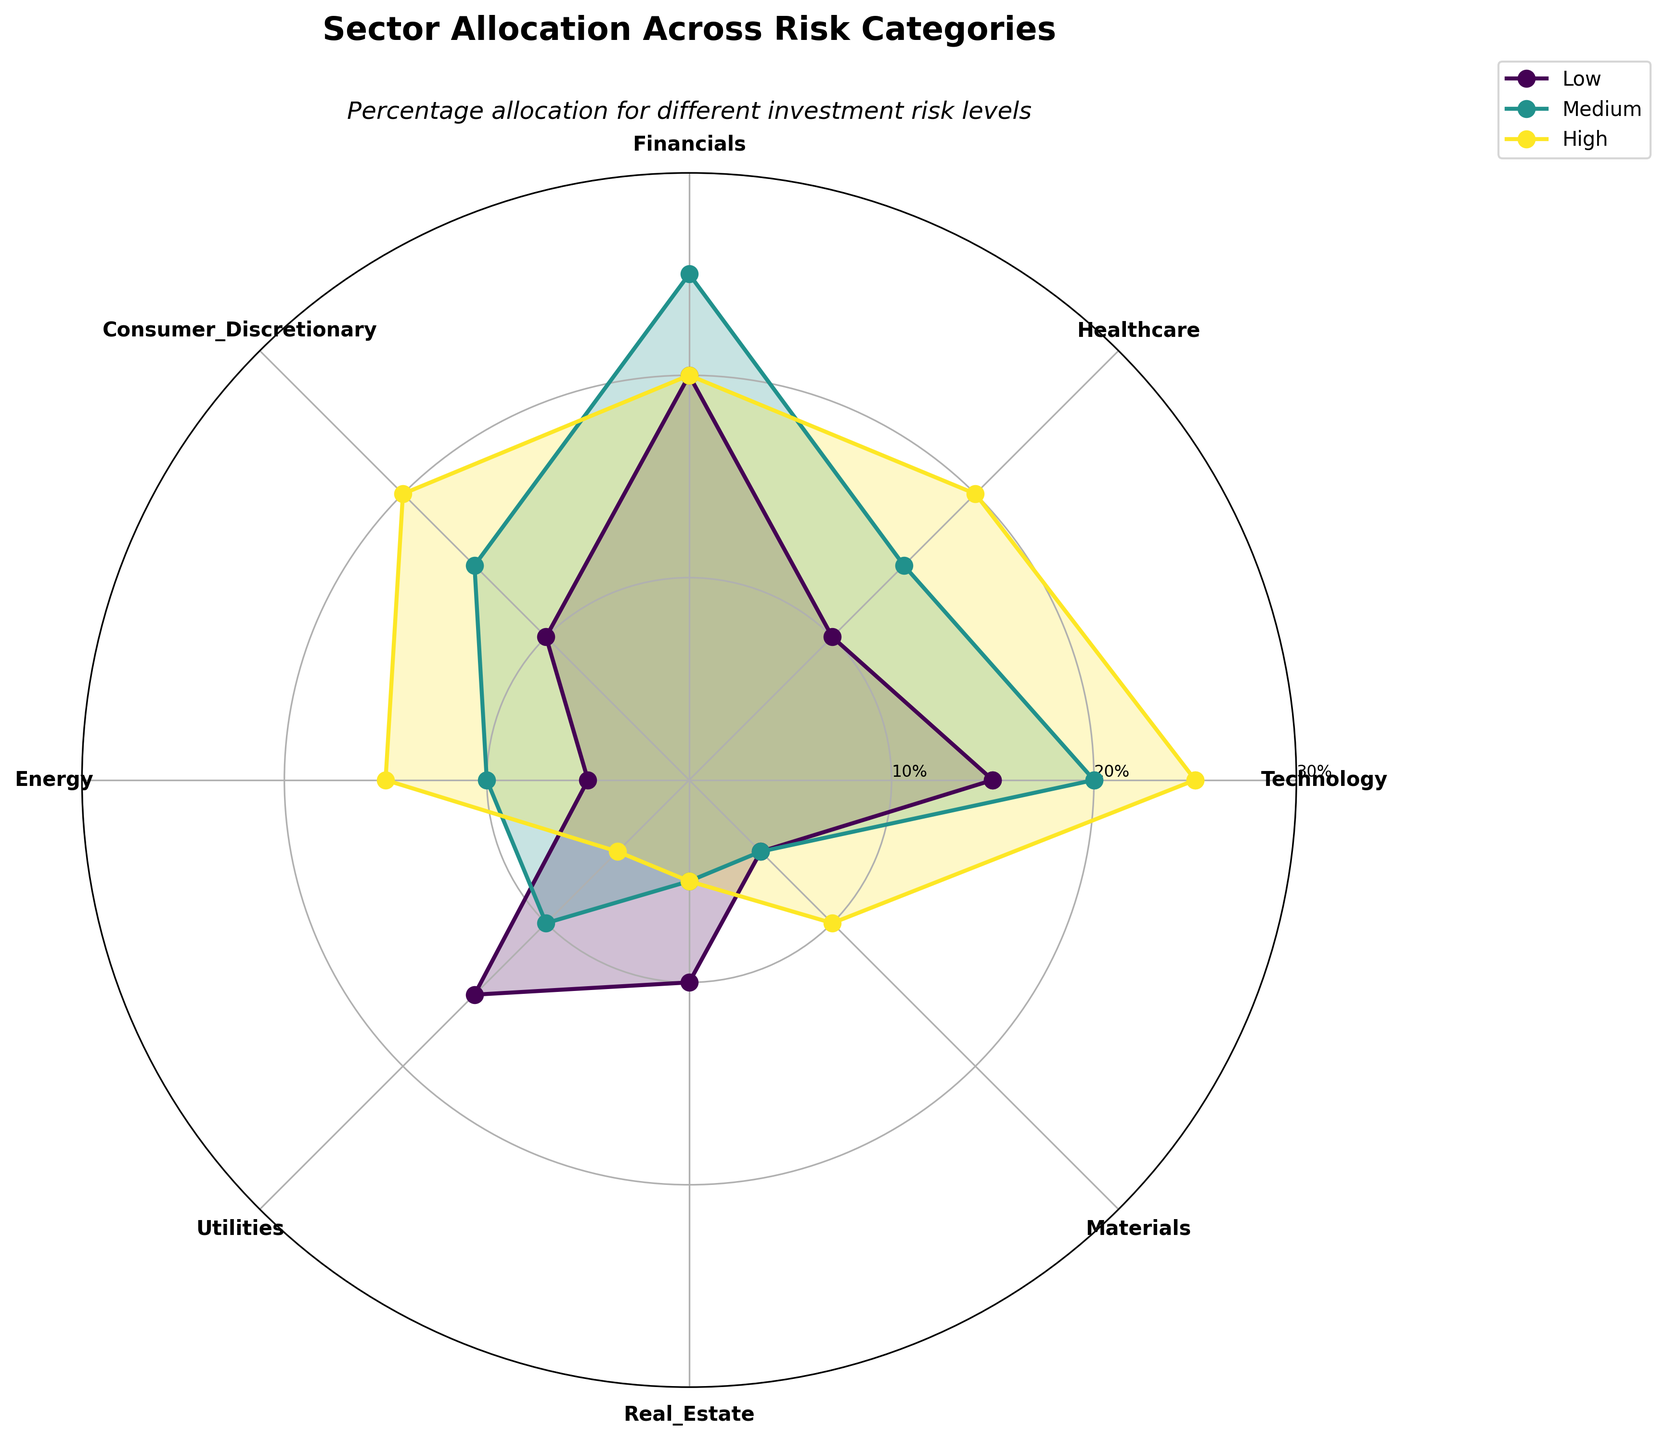What is the title of the polar chart? The title is located at the top of the chart. It is written in bold font and is larger than other text in the chart.
Answer: Sector Allocation Across Risk Categories Which sector has the highest percentage allocation in the high-risk category? By looking at the segments for each sector in the high-risk category (colored distinctly), the Technology sector has the highest value reaching 25%.
Answer: Technology What is the percentage allocation for Financials in the medium-risk category? Locate the section for Financials and look at the medium-risk category line and shading. The percentage indicated here is 25%.
Answer: 25% Compare the allocation of Utilities in the low-risk category to the high-risk category. Which one is higher? Find the sector marked as Utilities and compare the values for low-risk and high-risk categories. The low-risk category shows 15%, while the high-risk category shows 5%. Thus, low-risk has a higher allocation.
Answer: Low-risk Which risk category has the largest allocation in the Energy sector? Look at the Energy sector and compare the values for low, medium, and high risk. The high-risk category, indicated by a value reaching 15%, is the largest.
Answer: High-risk What is the average percentage allocation of Materials across all risk categories? For Materials: the percentages are 5% (Low), 5% (Medium), and 10% (High). The average is calculated as (5+5+10)/3 = 20/3 = ~6.67%.
Answer: ~6.67% Is the allocation for Consumer Discretionary higher in the high-risk category or the low-risk category? Check the Consumer Discretionary sector and compare the lines for low-risk and high-risk. The high-risk category shows 20%, while the low-risk category shows 10%.
Answer: High-risk Compare Real Estate allocation between low and medium-risk categories and find the difference. For Real Estate: Low-risk shows 10% and Medium-risk shows 5%. The difference is 10% - 5% = 5%.
Answer: 5% Which sector has an equal percentage allocation in both medium and high-risk categories? Identify the sector(s) where the medium and high-risk values are the same. Real Estate has both at 5%.
Answer: Real Estate What is the total percentage allocation for the Healthcare sector across all risk categories? Healthcare sector percentages: Low (10%), Medium (15%), and High (20%). Sum them up: 10 + 15 + 20 = 45%.
Answer: 45% 